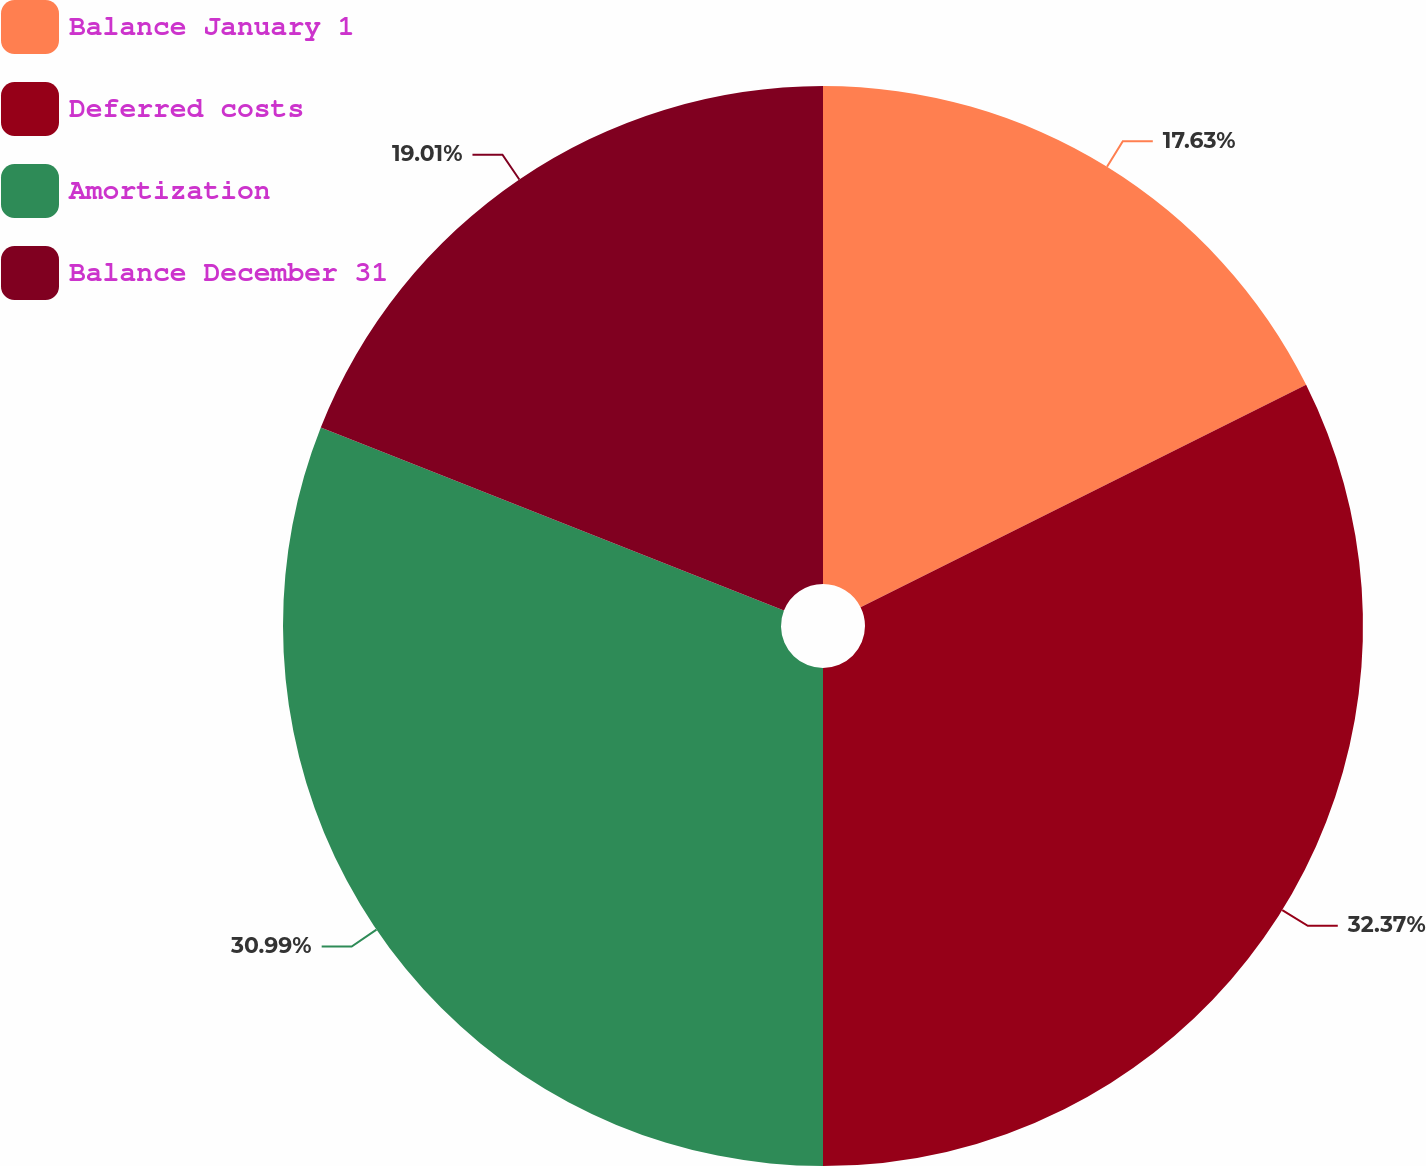Convert chart to OTSL. <chart><loc_0><loc_0><loc_500><loc_500><pie_chart><fcel>Balance January 1<fcel>Deferred costs<fcel>Amortization<fcel>Balance December 31<nl><fcel>17.63%<fcel>32.37%<fcel>30.99%<fcel>19.01%<nl></chart> 